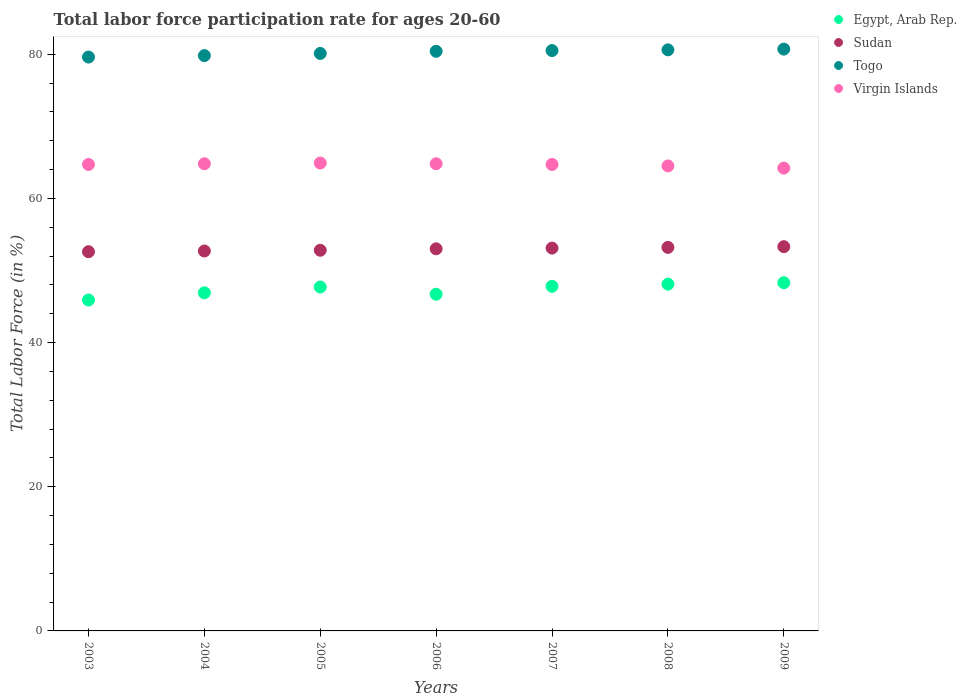What is the labor force participation rate in Egypt, Arab Rep. in 2008?
Your response must be concise. 48.1. Across all years, what is the maximum labor force participation rate in Sudan?
Keep it short and to the point. 53.3. Across all years, what is the minimum labor force participation rate in Togo?
Offer a very short reply. 79.6. In which year was the labor force participation rate in Egypt, Arab Rep. maximum?
Your answer should be compact. 2009. What is the total labor force participation rate in Sudan in the graph?
Your response must be concise. 370.7. What is the difference between the labor force participation rate in Virgin Islands in 2003 and that in 2005?
Keep it short and to the point. -0.2. What is the difference between the labor force participation rate in Sudan in 2006 and the labor force participation rate in Egypt, Arab Rep. in 2009?
Keep it short and to the point. 4.7. What is the average labor force participation rate in Virgin Islands per year?
Make the answer very short. 64.66. In the year 2007, what is the difference between the labor force participation rate in Virgin Islands and labor force participation rate in Egypt, Arab Rep.?
Keep it short and to the point. 16.9. In how many years, is the labor force participation rate in Togo greater than 72 %?
Provide a short and direct response. 7. What is the ratio of the labor force participation rate in Sudan in 2007 to that in 2009?
Offer a terse response. 1. Is the labor force participation rate in Virgin Islands in 2003 less than that in 2004?
Offer a terse response. Yes. Is the difference between the labor force participation rate in Virgin Islands in 2004 and 2009 greater than the difference between the labor force participation rate in Egypt, Arab Rep. in 2004 and 2009?
Provide a succinct answer. Yes. What is the difference between the highest and the second highest labor force participation rate in Sudan?
Your answer should be compact. 0.1. What is the difference between the highest and the lowest labor force participation rate in Sudan?
Your answer should be compact. 0.7. Is the sum of the labor force participation rate in Togo in 2007 and 2008 greater than the maximum labor force participation rate in Virgin Islands across all years?
Provide a short and direct response. Yes. Is it the case that in every year, the sum of the labor force participation rate in Virgin Islands and labor force participation rate in Sudan  is greater than the sum of labor force participation rate in Togo and labor force participation rate in Egypt, Arab Rep.?
Your response must be concise. Yes. Is it the case that in every year, the sum of the labor force participation rate in Egypt, Arab Rep. and labor force participation rate in Sudan  is greater than the labor force participation rate in Togo?
Your answer should be compact. Yes. Does the labor force participation rate in Sudan monotonically increase over the years?
Your answer should be very brief. Yes. Is the labor force participation rate in Sudan strictly greater than the labor force participation rate in Egypt, Arab Rep. over the years?
Provide a succinct answer. Yes. Are the values on the major ticks of Y-axis written in scientific E-notation?
Offer a very short reply. No. Where does the legend appear in the graph?
Make the answer very short. Top right. How are the legend labels stacked?
Your response must be concise. Vertical. What is the title of the graph?
Provide a succinct answer. Total labor force participation rate for ages 20-60. Does "Russian Federation" appear as one of the legend labels in the graph?
Your answer should be compact. No. What is the label or title of the X-axis?
Keep it short and to the point. Years. What is the label or title of the Y-axis?
Your answer should be very brief. Total Labor Force (in %). What is the Total Labor Force (in %) of Egypt, Arab Rep. in 2003?
Provide a short and direct response. 45.9. What is the Total Labor Force (in %) in Sudan in 2003?
Offer a terse response. 52.6. What is the Total Labor Force (in %) of Togo in 2003?
Ensure brevity in your answer.  79.6. What is the Total Labor Force (in %) of Virgin Islands in 2003?
Give a very brief answer. 64.7. What is the Total Labor Force (in %) in Egypt, Arab Rep. in 2004?
Provide a succinct answer. 46.9. What is the Total Labor Force (in %) of Sudan in 2004?
Your answer should be compact. 52.7. What is the Total Labor Force (in %) in Togo in 2004?
Offer a terse response. 79.8. What is the Total Labor Force (in %) of Virgin Islands in 2004?
Ensure brevity in your answer.  64.8. What is the Total Labor Force (in %) of Egypt, Arab Rep. in 2005?
Give a very brief answer. 47.7. What is the Total Labor Force (in %) in Sudan in 2005?
Your answer should be compact. 52.8. What is the Total Labor Force (in %) in Togo in 2005?
Ensure brevity in your answer.  80.1. What is the Total Labor Force (in %) of Virgin Islands in 2005?
Offer a terse response. 64.9. What is the Total Labor Force (in %) of Egypt, Arab Rep. in 2006?
Give a very brief answer. 46.7. What is the Total Labor Force (in %) in Sudan in 2006?
Give a very brief answer. 53. What is the Total Labor Force (in %) of Togo in 2006?
Make the answer very short. 80.4. What is the Total Labor Force (in %) in Virgin Islands in 2006?
Give a very brief answer. 64.8. What is the Total Labor Force (in %) in Egypt, Arab Rep. in 2007?
Your response must be concise. 47.8. What is the Total Labor Force (in %) of Sudan in 2007?
Ensure brevity in your answer.  53.1. What is the Total Labor Force (in %) of Togo in 2007?
Make the answer very short. 80.5. What is the Total Labor Force (in %) of Virgin Islands in 2007?
Your response must be concise. 64.7. What is the Total Labor Force (in %) in Egypt, Arab Rep. in 2008?
Keep it short and to the point. 48.1. What is the Total Labor Force (in %) in Sudan in 2008?
Your answer should be compact. 53.2. What is the Total Labor Force (in %) of Togo in 2008?
Provide a succinct answer. 80.6. What is the Total Labor Force (in %) of Virgin Islands in 2008?
Offer a very short reply. 64.5. What is the Total Labor Force (in %) of Egypt, Arab Rep. in 2009?
Give a very brief answer. 48.3. What is the Total Labor Force (in %) in Sudan in 2009?
Offer a terse response. 53.3. What is the Total Labor Force (in %) of Togo in 2009?
Keep it short and to the point. 80.7. What is the Total Labor Force (in %) in Virgin Islands in 2009?
Your response must be concise. 64.2. Across all years, what is the maximum Total Labor Force (in %) of Egypt, Arab Rep.?
Provide a short and direct response. 48.3. Across all years, what is the maximum Total Labor Force (in %) of Sudan?
Provide a succinct answer. 53.3. Across all years, what is the maximum Total Labor Force (in %) of Togo?
Your answer should be compact. 80.7. Across all years, what is the maximum Total Labor Force (in %) in Virgin Islands?
Your answer should be compact. 64.9. Across all years, what is the minimum Total Labor Force (in %) in Egypt, Arab Rep.?
Ensure brevity in your answer.  45.9. Across all years, what is the minimum Total Labor Force (in %) in Sudan?
Offer a terse response. 52.6. Across all years, what is the minimum Total Labor Force (in %) in Togo?
Ensure brevity in your answer.  79.6. Across all years, what is the minimum Total Labor Force (in %) of Virgin Islands?
Your answer should be very brief. 64.2. What is the total Total Labor Force (in %) in Egypt, Arab Rep. in the graph?
Your answer should be very brief. 331.4. What is the total Total Labor Force (in %) in Sudan in the graph?
Your answer should be very brief. 370.7. What is the total Total Labor Force (in %) of Togo in the graph?
Provide a short and direct response. 561.7. What is the total Total Labor Force (in %) of Virgin Islands in the graph?
Your answer should be compact. 452.6. What is the difference between the Total Labor Force (in %) of Egypt, Arab Rep. in 2003 and that in 2005?
Keep it short and to the point. -1.8. What is the difference between the Total Labor Force (in %) of Virgin Islands in 2003 and that in 2005?
Keep it short and to the point. -0.2. What is the difference between the Total Labor Force (in %) in Egypt, Arab Rep. in 2003 and that in 2006?
Offer a terse response. -0.8. What is the difference between the Total Labor Force (in %) of Sudan in 2003 and that in 2006?
Offer a very short reply. -0.4. What is the difference between the Total Labor Force (in %) of Togo in 2003 and that in 2006?
Offer a very short reply. -0.8. What is the difference between the Total Labor Force (in %) in Egypt, Arab Rep. in 2003 and that in 2007?
Offer a very short reply. -1.9. What is the difference between the Total Labor Force (in %) of Togo in 2003 and that in 2007?
Provide a short and direct response. -0.9. What is the difference between the Total Labor Force (in %) in Virgin Islands in 2003 and that in 2007?
Provide a short and direct response. 0. What is the difference between the Total Labor Force (in %) of Sudan in 2003 and that in 2008?
Your answer should be compact. -0.6. What is the difference between the Total Labor Force (in %) in Togo in 2003 and that in 2008?
Provide a succinct answer. -1. What is the difference between the Total Labor Force (in %) of Sudan in 2003 and that in 2009?
Give a very brief answer. -0.7. What is the difference between the Total Labor Force (in %) of Togo in 2003 and that in 2009?
Make the answer very short. -1.1. What is the difference between the Total Labor Force (in %) in Egypt, Arab Rep. in 2004 and that in 2005?
Provide a succinct answer. -0.8. What is the difference between the Total Labor Force (in %) of Sudan in 2004 and that in 2005?
Your answer should be very brief. -0.1. What is the difference between the Total Labor Force (in %) of Togo in 2004 and that in 2005?
Offer a terse response. -0.3. What is the difference between the Total Labor Force (in %) of Virgin Islands in 2004 and that in 2005?
Offer a terse response. -0.1. What is the difference between the Total Labor Force (in %) in Egypt, Arab Rep. in 2004 and that in 2006?
Keep it short and to the point. 0.2. What is the difference between the Total Labor Force (in %) in Togo in 2004 and that in 2006?
Make the answer very short. -0.6. What is the difference between the Total Labor Force (in %) of Virgin Islands in 2004 and that in 2006?
Provide a succinct answer. 0. What is the difference between the Total Labor Force (in %) of Egypt, Arab Rep. in 2004 and that in 2007?
Offer a very short reply. -0.9. What is the difference between the Total Labor Force (in %) of Egypt, Arab Rep. in 2004 and that in 2008?
Keep it short and to the point. -1.2. What is the difference between the Total Labor Force (in %) of Sudan in 2004 and that in 2008?
Give a very brief answer. -0.5. What is the difference between the Total Labor Force (in %) in Virgin Islands in 2004 and that in 2008?
Your answer should be compact. 0.3. What is the difference between the Total Labor Force (in %) of Egypt, Arab Rep. in 2004 and that in 2009?
Offer a very short reply. -1.4. What is the difference between the Total Labor Force (in %) of Togo in 2004 and that in 2009?
Provide a succinct answer. -0.9. What is the difference between the Total Labor Force (in %) of Virgin Islands in 2004 and that in 2009?
Your answer should be very brief. 0.6. What is the difference between the Total Labor Force (in %) in Sudan in 2005 and that in 2006?
Offer a terse response. -0.2. What is the difference between the Total Labor Force (in %) of Togo in 2005 and that in 2006?
Keep it short and to the point. -0.3. What is the difference between the Total Labor Force (in %) in Togo in 2005 and that in 2007?
Keep it short and to the point. -0.4. What is the difference between the Total Labor Force (in %) in Virgin Islands in 2005 and that in 2007?
Offer a very short reply. 0.2. What is the difference between the Total Labor Force (in %) of Virgin Islands in 2005 and that in 2008?
Your answer should be compact. 0.4. What is the difference between the Total Labor Force (in %) of Sudan in 2005 and that in 2009?
Offer a very short reply. -0.5. What is the difference between the Total Labor Force (in %) in Togo in 2005 and that in 2009?
Your answer should be very brief. -0.6. What is the difference between the Total Labor Force (in %) in Egypt, Arab Rep. in 2006 and that in 2008?
Give a very brief answer. -1.4. What is the difference between the Total Labor Force (in %) of Togo in 2006 and that in 2009?
Offer a very short reply. -0.3. What is the difference between the Total Labor Force (in %) in Sudan in 2007 and that in 2008?
Ensure brevity in your answer.  -0.1. What is the difference between the Total Labor Force (in %) of Togo in 2007 and that in 2008?
Ensure brevity in your answer.  -0.1. What is the difference between the Total Labor Force (in %) of Egypt, Arab Rep. in 2007 and that in 2009?
Your response must be concise. -0.5. What is the difference between the Total Labor Force (in %) in Togo in 2007 and that in 2009?
Your response must be concise. -0.2. What is the difference between the Total Labor Force (in %) in Virgin Islands in 2008 and that in 2009?
Make the answer very short. 0.3. What is the difference between the Total Labor Force (in %) in Egypt, Arab Rep. in 2003 and the Total Labor Force (in %) in Togo in 2004?
Ensure brevity in your answer.  -33.9. What is the difference between the Total Labor Force (in %) in Egypt, Arab Rep. in 2003 and the Total Labor Force (in %) in Virgin Islands in 2004?
Offer a very short reply. -18.9. What is the difference between the Total Labor Force (in %) in Sudan in 2003 and the Total Labor Force (in %) in Togo in 2004?
Offer a very short reply. -27.2. What is the difference between the Total Labor Force (in %) of Togo in 2003 and the Total Labor Force (in %) of Virgin Islands in 2004?
Offer a terse response. 14.8. What is the difference between the Total Labor Force (in %) in Egypt, Arab Rep. in 2003 and the Total Labor Force (in %) in Sudan in 2005?
Your answer should be compact. -6.9. What is the difference between the Total Labor Force (in %) of Egypt, Arab Rep. in 2003 and the Total Labor Force (in %) of Togo in 2005?
Offer a very short reply. -34.2. What is the difference between the Total Labor Force (in %) of Egypt, Arab Rep. in 2003 and the Total Labor Force (in %) of Virgin Islands in 2005?
Provide a short and direct response. -19. What is the difference between the Total Labor Force (in %) of Sudan in 2003 and the Total Labor Force (in %) of Togo in 2005?
Ensure brevity in your answer.  -27.5. What is the difference between the Total Labor Force (in %) in Egypt, Arab Rep. in 2003 and the Total Labor Force (in %) in Sudan in 2006?
Ensure brevity in your answer.  -7.1. What is the difference between the Total Labor Force (in %) in Egypt, Arab Rep. in 2003 and the Total Labor Force (in %) in Togo in 2006?
Provide a short and direct response. -34.5. What is the difference between the Total Labor Force (in %) of Egypt, Arab Rep. in 2003 and the Total Labor Force (in %) of Virgin Islands in 2006?
Give a very brief answer. -18.9. What is the difference between the Total Labor Force (in %) of Sudan in 2003 and the Total Labor Force (in %) of Togo in 2006?
Keep it short and to the point. -27.8. What is the difference between the Total Labor Force (in %) in Sudan in 2003 and the Total Labor Force (in %) in Virgin Islands in 2006?
Offer a terse response. -12.2. What is the difference between the Total Labor Force (in %) of Egypt, Arab Rep. in 2003 and the Total Labor Force (in %) of Togo in 2007?
Provide a succinct answer. -34.6. What is the difference between the Total Labor Force (in %) in Egypt, Arab Rep. in 2003 and the Total Labor Force (in %) in Virgin Islands in 2007?
Ensure brevity in your answer.  -18.8. What is the difference between the Total Labor Force (in %) in Sudan in 2003 and the Total Labor Force (in %) in Togo in 2007?
Provide a succinct answer. -27.9. What is the difference between the Total Labor Force (in %) in Sudan in 2003 and the Total Labor Force (in %) in Virgin Islands in 2007?
Your answer should be compact. -12.1. What is the difference between the Total Labor Force (in %) of Egypt, Arab Rep. in 2003 and the Total Labor Force (in %) of Sudan in 2008?
Offer a terse response. -7.3. What is the difference between the Total Labor Force (in %) in Egypt, Arab Rep. in 2003 and the Total Labor Force (in %) in Togo in 2008?
Offer a terse response. -34.7. What is the difference between the Total Labor Force (in %) in Egypt, Arab Rep. in 2003 and the Total Labor Force (in %) in Virgin Islands in 2008?
Ensure brevity in your answer.  -18.6. What is the difference between the Total Labor Force (in %) of Sudan in 2003 and the Total Labor Force (in %) of Togo in 2008?
Your answer should be compact. -28. What is the difference between the Total Labor Force (in %) in Sudan in 2003 and the Total Labor Force (in %) in Virgin Islands in 2008?
Your answer should be compact. -11.9. What is the difference between the Total Labor Force (in %) of Egypt, Arab Rep. in 2003 and the Total Labor Force (in %) of Togo in 2009?
Offer a very short reply. -34.8. What is the difference between the Total Labor Force (in %) in Egypt, Arab Rep. in 2003 and the Total Labor Force (in %) in Virgin Islands in 2009?
Offer a terse response. -18.3. What is the difference between the Total Labor Force (in %) of Sudan in 2003 and the Total Labor Force (in %) of Togo in 2009?
Offer a very short reply. -28.1. What is the difference between the Total Labor Force (in %) in Egypt, Arab Rep. in 2004 and the Total Labor Force (in %) in Togo in 2005?
Keep it short and to the point. -33.2. What is the difference between the Total Labor Force (in %) in Sudan in 2004 and the Total Labor Force (in %) in Togo in 2005?
Your answer should be compact. -27.4. What is the difference between the Total Labor Force (in %) of Sudan in 2004 and the Total Labor Force (in %) of Virgin Islands in 2005?
Your response must be concise. -12.2. What is the difference between the Total Labor Force (in %) in Egypt, Arab Rep. in 2004 and the Total Labor Force (in %) in Togo in 2006?
Offer a terse response. -33.5. What is the difference between the Total Labor Force (in %) in Egypt, Arab Rep. in 2004 and the Total Labor Force (in %) in Virgin Islands in 2006?
Make the answer very short. -17.9. What is the difference between the Total Labor Force (in %) of Sudan in 2004 and the Total Labor Force (in %) of Togo in 2006?
Your answer should be compact. -27.7. What is the difference between the Total Labor Force (in %) of Sudan in 2004 and the Total Labor Force (in %) of Virgin Islands in 2006?
Your response must be concise. -12.1. What is the difference between the Total Labor Force (in %) in Togo in 2004 and the Total Labor Force (in %) in Virgin Islands in 2006?
Keep it short and to the point. 15. What is the difference between the Total Labor Force (in %) in Egypt, Arab Rep. in 2004 and the Total Labor Force (in %) in Sudan in 2007?
Make the answer very short. -6.2. What is the difference between the Total Labor Force (in %) of Egypt, Arab Rep. in 2004 and the Total Labor Force (in %) of Togo in 2007?
Your response must be concise. -33.6. What is the difference between the Total Labor Force (in %) of Egypt, Arab Rep. in 2004 and the Total Labor Force (in %) of Virgin Islands in 2007?
Your answer should be very brief. -17.8. What is the difference between the Total Labor Force (in %) in Sudan in 2004 and the Total Labor Force (in %) in Togo in 2007?
Your answer should be compact. -27.8. What is the difference between the Total Labor Force (in %) in Sudan in 2004 and the Total Labor Force (in %) in Virgin Islands in 2007?
Provide a short and direct response. -12. What is the difference between the Total Labor Force (in %) in Togo in 2004 and the Total Labor Force (in %) in Virgin Islands in 2007?
Your answer should be very brief. 15.1. What is the difference between the Total Labor Force (in %) in Egypt, Arab Rep. in 2004 and the Total Labor Force (in %) in Sudan in 2008?
Your answer should be very brief. -6.3. What is the difference between the Total Labor Force (in %) in Egypt, Arab Rep. in 2004 and the Total Labor Force (in %) in Togo in 2008?
Your answer should be very brief. -33.7. What is the difference between the Total Labor Force (in %) of Egypt, Arab Rep. in 2004 and the Total Labor Force (in %) of Virgin Islands in 2008?
Make the answer very short. -17.6. What is the difference between the Total Labor Force (in %) of Sudan in 2004 and the Total Labor Force (in %) of Togo in 2008?
Ensure brevity in your answer.  -27.9. What is the difference between the Total Labor Force (in %) in Egypt, Arab Rep. in 2004 and the Total Labor Force (in %) in Togo in 2009?
Keep it short and to the point. -33.8. What is the difference between the Total Labor Force (in %) in Egypt, Arab Rep. in 2004 and the Total Labor Force (in %) in Virgin Islands in 2009?
Offer a terse response. -17.3. What is the difference between the Total Labor Force (in %) of Togo in 2004 and the Total Labor Force (in %) of Virgin Islands in 2009?
Offer a terse response. 15.6. What is the difference between the Total Labor Force (in %) in Egypt, Arab Rep. in 2005 and the Total Labor Force (in %) in Togo in 2006?
Keep it short and to the point. -32.7. What is the difference between the Total Labor Force (in %) of Egypt, Arab Rep. in 2005 and the Total Labor Force (in %) of Virgin Islands in 2006?
Your answer should be compact. -17.1. What is the difference between the Total Labor Force (in %) in Sudan in 2005 and the Total Labor Force (in %) in Togo in 2006?
Your answer should be very brief. -27.6. What is the difference between the Total Labor Force (in %) of Sudan in 2005 and the Total Labor Force (in %) of Virgin Islands in 2006?
Make the answer very short. -12. What is the difference between the Total Labor Force (in %) of Togo in 2005 and the Total Labor Force (in %) of Virgin Islands in 2006?
Keep it short and to the point. 15.3. What is the difference between the Total Labor Force (in %) in Egypt, Arab Rep. in 2005 and the Total Labor Force (in %) in Sudan in 2007?
Give a very brief answer. -5.4. What is the difference between the Total Labor Force (in %) of Egypt, Arab Rep. in 2005 and the Total Labor Force (in %) of Togo in 2007?
Offer a very short reply. -32.8. What is the difference between the Total Labor Force (in %) of Egypt, Arab Rep. in 2005 and the Total Labor Force (in %) of Virgin Islands in 2007?
Ensure brevity in your answer.  -17. What is the difference between the Total Labor Force (in %) in Sudan in 2005 and the Total Labor Force (in %) in Togo in 2007?
Ensure brevity in your answer.  -27.7. What is the difference between the Total Labor Force (in %) of Togo in 2005 and the Total Labor Force (in %) of Virgin Islands in 2007?
Offer a terse response. 15.4. What is the difference between the Total Labor Force (in %) of Egypt, Arab Rep. in 2005 and the Total Labor Force (in %) of Togo in 2008?
Provide a succinct answer. -32.9. What is the difference between the Total Labor Force (in %) of Egypt, Arab Rep. in 2005 and the Total Labor Force (in %) of Virgin Islands in 2008?
Offer a very short reply. -16.8. What is the difference between the Total Labor Force (in %) of Sudan in 2005 and the Total Labor Force (in %) of Togo in 2008?
Your response must be concise. -27.8. What is the difference between the Total Labor Force (in %) of Sudan in 2005 and the Total Labor Force (in %) of Virgin Islands in 2008?
Ensure brevity in your answer.  -11.7. What is the difference between the Total Labor Force (in %) in Togo in 2005 and the Total Labor Force (in %) in Virgin Islands in 2008?
Offer a terse response. 15.6. What is the difference between the Total Labor Force (in %) of Egypt, Arab Rep. in 2005 and the Total Labor Force (in %) of Togo in 2009?
Keep it short and to the point. -33. What is the difference between the Total Labor Force (in %) in Egypt, Arab Rep. in 2005 and the Total Labor Force (in %) in Virgin Islands in 2009?
Offer a terse response. -16.5. What is the difference between the Total Labor Force (in %) in Sudan in 2005 and the Total Labor Force (in %) in Togo in 2009?
Your response must be concise. -27.9. What is the difference between the Total Labor Force (in %) in Sudan in 2005 and the Total Labor Force (in %) in Virgin Islands in 2009?
Make the answer very short. -11.4. What is the difference between the Total Labor Force (in %) of Egypt, Arab Rep. in 2006 and the Total Labor Force (in %) of Sudan in 2007?
Make the answer very short. -6.4. What is the difference between the Total Labor Force (in %) of Egypt, Arab Rep. in 2006 and the Total Labor Force (in %) of Togo in 2007?
Offer a very short reply. -33.8. What is the difference between the Total Labor Force (in %) of Egypt, Arab Rep. in 2006 and the Total Labor Force (in %) of Virgin Islands in 2007?
Your answer should be compact. -18. What is the difference between the Total Labor Force (in %) in Sudan in 2006 and the Total Labor Force (in %) in Togo in 2007?
Ensure brevity in your answer.  -27.5. What is the difference between the Total Labor Force (in %) of Sudan in 2006 and the Total Labor Force (in %) of Virgin Islands in 2007?
Give a very brief answer. -11.7. What is the difference between the Total Labor Force (in %) of Egypt, Arab Rep. in 2006 and the Total Labor Force (in %) of Togo in 2008?
Ensure brevity in your answer.  -33.9. What is the difference between the Total Labor Force (in %) of Egypt, Arab Rep. in 2006 and the Total Labor Force (in %) of Virgin Islands in 2008?
Make the answer very short. -17.8. What is the difference between the Total Labor Force (in %) in Sudan in 2006 and the Total Labor Force (in %) in Togo in 2008?
Keep it short and to the point. -27.6. What is the difference between the Total Labor Force (in %) of Sudan in 2006 and the Total Labor Force (in %) of Virgin Islands in 2008?
Provide a short and direct response. -11.5. What is the difference between the Total Labor Force (in %) of Togo in 2006 and the Total Labor Force (in %) of Virgin Islands in 2008?
Offer a terse response. 15.9. What is the difference between the Total Labor Force (in %) in Egypt, Arab Rep. in 2006 and the Total Labor Force (in %) in Sudan in 2009?
Your answer should be very brief. -6.6. What is the difference between the Total Labor Force (in %) in Egypt, Arab Rep. in 2006 and the Total Labor Force (in %) in Togo in 2009?
Offer a very short reply. -34. What is the difference between the Total Labor Force (in %) in Egypt, Arab Rep. in 2006 and the Total Labor Force (in %) in Virgin Islands in 2009?
Your answer should be very brief. -17.5. What is the difference between the Total Labor Force (in %) of Sudan in 2006 and the Total Labor Force (in %) of Togo in 2009?
Ensure brevity in your answer.  -27.7. What is the difference between the Total Labor Force (in %) of Sudan in 2006 and the Total Labor Force (in %) of Virgin Islands in 2009?
Provide a short and direct response. -11.2. What is the difference between the Total Labor Force (in %) in Togo in 2006 and the Total Labor Force (in %) in Virgin Islands in 2009?
Provide a succinct answer. 16.2. What is the difference between the Total Labor Force (in %) in Egypt, Arab Rep. in 2007 and the Total Labor Force (in %) in Togo in 2008?
Give a very brief answer. -32.8. What is the difference between the Total Labor Force (in %) of Egypt, Arab Rep. in 2007 and the Total Labor Force (in %) of Virgin Islands in 2008?
Provide a succinct answer. -16.7. What is the difference between the Total Labor Force (in %) of Sudan in 2007 and the Total Labor Force (in %) of Togo in 2008?
Give a very brief answer. -27.5. What is the difference between the Total Labor Force (in %) of Sudan in 2007 and the Total Labor Force (in %) of Virgin Islands in 2008?
Offer a very short reply. -11.4. What is the difference between the Total Labor Force (in %) in Togo in 2007 and the Total Labor Force (in %) in Virgin Islands in 2008?
Give a very brief answer. 16. What is the difference between the Total Labor Force (in %) in Egypt, Arab Rep. in 2007 and the Total Labor Force (in %) in Togo in 2009?
Provide a succinct answer. -32.9. What is the difference between the Total Labor Force (in %) of Egypt, Arab Rep. in 2007 and the Total Labor Force (in %) of Virgin Islands in 2009?
Your answer should be compact. -16.4. What is the difference between the Total Labor Force (in %) in Sudan in 2007 and the Total Labor Force (in %) in Togo in 2009?
Keep it short and to the point. -27.6. What is the difference between the Total Labor Force (in %) in Togo in 2007 and the Total Labor Force (in %) in Virgin Islands in 2009?
Give a very brief answer. 16.3. What is the difference between the Total Labor Force (in %) in Egypt, Arab Rep. in 2008 and the Total Labor Force (in %) in Togo in 2009?
Give a very brief answer. -32.6. What is the difference between the Total Labor Force (in %) of Egypt, Arab Rep. in 2008 and the Total Labor Force (in %) of Virgin Islands in 2009?
Your response must be concise. -16.1. What is the difference between the Total Labor Force (in %) in Sudan in 2008 and the Total Labor Force (in %) in Togo in 2009?
Keep it short and to the point. -27.5. What is the average Total Labor Force (in %) in Egypt, Arab Rep. per year?
Provide a succinct answer. 47.34. What is the average Total Labor Force (in %) of Sudan per year?
Ensure brevity in your answer.  52.96. What is the average Total Labor Force (in %) of Togo per year?
Give a very brief answer. 80.24. What is the average Total Labor Force (in %) in Virgin Islands per year?
Keep it short and to the point. 64.66. In the year 2003, what is the difference between the Total Labor Force (in %) in Egypt, Arab Rep. and Total Labor Force (in %) in Togo?
Provide a succinct answer. -33.7. In the year 2003, what is the difference between the Total Labor Force (in %) in Egypt, Arab Rep. and Total Labor Force (in %) in Virgin Islands?
Make the answer very short. -18.8. In the year 2004, what is the difference between the Total Labor Force (in %) of Egypt, Arab Rep. and Total Labor Force (in %) of Sudan?
Offer a terse response. -5.8. In the year 2004, what is the difference between the Total Labor Force (in %) of Egypt, Arab Rep. and Total Labor Force (in %) of Togo?
Your answer should be very brief. -32.9. In the year 2004, what is the difference between the Total Labor Force (in %) in Egypt, Arab Rep. and Total Labor Force (in %) in Virgin Islands?
Your answer should be compact. -17.9. In the year 2004, what is the difference between the Total Labor Force (in %) in Sudan and Total Labor Force (in %) in Togo?
Ensure brevity in your answer.  -27.1. In the year 2004, what is the difference between the Total Labor Force (in %) of Togo and Total Labor Force (in %) of Virgin Islands?
Offer a very short reply. 15. In the year 2005, what is the difference between the Total Labor Force (in %) in Egypt, Arab Rep. and Total Labor Force (in %) in Sudan?
Ensure brevity in your answer.  -5.1. In the year 2005, what is the difference between the Total Labor Force (in %) of Egypt, Arab Rep. and Total Labor Force (in %) of Togo?
Your response must be concise. -32.4. In the year 2005, what is the difference between the Total Labor Force (in %) of Egypt, Arab Rep. and Total Labor Force (in %) of Virgin Islands?
Your response must be concise. -17.2. In the year 2005, what is the difference between the Total Labor Force (in %) of Sudan and Total Labor Force (in %) of Togo?
Your response must be concise. -27.3. In the year 2005, what is the difference between the Total Labor Force (in %) of Togo and Total Labor Force (in %) of Virgin Islands?
Your answer should be compact. 15.2. In the year 2006, what is the difference between the Total Labor Force (in %) in Egypt, Arab Rep. and Total Labor Force (in %) in Sudan?
Offer a terse response. -6.3. In the year 2006, what is the difference between the Total Labor Force (in %) in Egypt, Arab Rep. and Total Labor Force (in %) in Togo?
Provide a succinct answer. -33.7. In the year 2006, what is the difference between the Total Labor Force (in %) of Egypt, Arab Rep. and Total Labor Force (in %) of Virgin Islands?
Ensure brevity in your answer.  -18.1. In the year 2006, what is the difference between the Total Labor Force (in %) of Sudan and Total Labor Force (in %) of Togo?
Your answer should be very brief. -27.4. In the year 2007, what is the difference between the Total Labor Force (in %) of Egypt, Arab Rep. and Total Labor Force (in %) of Sudan?
Provide a succinct answer. -5.3. In the year 2007, what is the difference between the Total Labor Force (in %) in Egypt, Arab Rep. and Total Labor Force (in %) in Togo?
Your response must be concise. -32.7. In the year 2007, what is the difference between the Total Labor Force (in %) of Egypt, Arab Rep. and Total Labor Force (in %) of Virgin Islands?
Provide a succinct answer. -16.9. In the year 2007, what is the difference between the Total Labor Force (in %) in Sudan and Total Labor Force (in %) in Togo?
Your answer should be compact. -27.4. In the year 2008, what is the difference between the Total Labor Force (in %) of Egypt, Arab Rep. and Total Labor Force (in %) of Togo?
Provide a short and direct response. -32.5. In the year 2008, what is the difference between the Total Labor Force (in %) in Egypt, Arab Rep. and Total Labor Force (in %) in Virgin Islands?
Your answer should be compact. -16.4. In the year 2008, what is the difference between the Total Labor Force (in %) of Sudan and Total Labor Force (in %) of Togo?
Provide a short and direct response. -27.4. In the year 2008, what is the difference between the Total Labor Force (in %) of Togo and Total Labor Force (in %) of Virgin Islands?
Your answer should be compact. 16.1. In the year 2009, what is the difference between the Total Labor Force (in %) in Egypt, Arab Rep. and Total Labor Force (in %) in Togo?
Keep it short and to the point. -32.4. In the year 2009, what is the difference between the Total Labor Force (in %) in Egypt, Arab Rep. and Total Labor Force (in %) in Virgin Islands?
Provide a succinct answer. -15.9. In the year 2009, what is the difference between the Total Labor Force (in %) in Sudan and Total Labor Force (in %) in Togo?
Offer a terse response. -27.4. In the year 2009, what is the difference between the Total Labor Force (in %) of Togo and Total Labor Force (in %) of Virgin Islands?
Provide a succinct answer. 16.5. What is the ratio of the Total Labor Force (in %) in Egypt, Arab Rep. in 2003 to that in 2004?
Provide a short and direct response. 0.98. What is the ratio of the Total Labor Force (in %) in Egypt, Arab Rep. in 2003 to that in 2005?
Provide a succinct answer. 0.96. What is the ratio of the Total Labor Force (in %) of Sudan in 2003 to that in 2005?
Your answer should be compact. 1. What is the ratio of the Total Labor Force (in %) of Virgin Islands in 2003 to that in 2005?
Ensure brevity in your answer.  1. What is the ratio of the Total Labor Force (in %) of Egypt, Arab Rep. in 2003 to that in 2006?
Your response must be concise. 0.98. What is the ratio of the Total Labor Force (in %) of Togo in 2003 to that in 2006?
Provide a short and direct response. 0.99. What is the ratio of the Total Labor Force (in %) of Egypt, Arab Rep. in 2003 to that in 2007?
Offer a terse response. 0.96. What is the ratio of the Total Labor Force (in %) in Sudan in 2003 to that in 2007?
Keep it short and to the point. 0.99. What is the ratio of the Total Labor Force (in %) in Egypt, Arab Rep. in 2003 to that in 2008?
Your response must be concise. 0.95. What is the ratio of the Total Labor Force (in %) in Sudan in 2003 to that in 2008?
Give a very brief answer. 0.99. What is the ratio of the Total Labor Force (in %) of Togo in 2003 to that in 2008?
Keep it short and to the point. 0.99. What is the ratio of the Total Labor Force (in %) in Egypt, Arab Rep. in 2003 to that in 2009?
Offer a very short reply. 0.95. What is the ratio of the Total Labor Force (in %) in Sudan in 2003 to that in 2009?
Your answer should be compact. 0.99. What is the ratio of the Total Labor Force (in %) of Togo in 2003 to that in 2009?
Give a very brief answer. 0.99. What is the ratio of the Total Labor Force (in %) in Virgin Islands in 2003 to that in 2009?
Keep it short and to the point. 1.01. What is the ratio of the Total Labor Force (in %) of Egypt, Arab Rep. in 2004 to that in 2005?
Keep it short and to the point. 0.98. What is the ratio of the Total Labor Force (in %) in Sudan in 2004 to that in 2005?
Make the answer very short. 1. What is the ratio of the Total Labor Force (in %) of Togo in 2004 to that in 2005?
Keep it short and to the point. 1. What is the ratio of the Total Labor Force (in %) of Virgin Islands in 2004 to that in 2005?
Your answer should be very brief. 1. What is the ratio of the Total Labor Force (in %) of Egypt, Arab Rep. in 2004 to that in 2006?
Ensure brevity in your answer.  1. What is the ratio of the Total Labor Force (in %) in Egypt, Arab Rep. in 2004 to that in 2007?
Your answer should be very brief. 0.98. What is the ratio of the Total Labor Force (in %) in Sudan in 2004 to that in 2007?
Your answer should be very brief. 0.99. What is the ratio of the Total Labor Force (in %) of Togo in 2004 to that in 2007?
Your answer should be very brief. 0.99. What is the ratio of the Total Labor Force (in %) in Virgin Islands in 2004 to that in 2007?
Give a very brief answer. 1. What is the ratio of the Total Labor Force (in %) of Egypt, Arab Rep. in 2004 to that in 2008?
Ensure brevity in your answer.  0.98. What is the ratio of the Total Labor Force (in %) of Sudan in 2004 to that in 2008?
Keep it short and to the point. 0.99. What is the ratio of the Total Labor Force (in %) in Virgin Islands in 2004 to that in 2008?
Offer a very short reply. 1. What is the ratio of the Total Labor Force (in %) of Sudan in 2004 to that in 2009?
Provide a succinct answer. 0.99. What is the ratio of the Total Labor Force (in %) of Togo in 2004 to that in 2009?
Your response must be concise. 0.99. What is the ratio of the Total Labor Force (in %) in Virgin Islands in 2004 to that in 2009?
Provide a succinct answer. 1.01. What is the ratio of the Total Labor Force (in %) in Egypt, Arab Rep. in 2005 to that in 2006?
Offer a terse response. 1.02. What is the ratio of the Total Labor Force (in %) of Sudan in 2005 to that in 2006?
Ensure brevity in your answer.  1. What is the ratio of the Total Labor Force (in %) of Virgin Islands in 2005 to that in 2006?
Provide a succinct answer. 1. What is the ratio of the Total Labor Force (in %) in Egypt, Arab Rep. in 2005 to that in 2007?
Provide a short and direct response. 1. What is the ratio of the Total Labor Force (in %) in Togo in 2005 to that in 2007?
Your answer should be compact. 0.99. What is the ratio of the Total Labor Force (in %) of Egypt, Arab Rep. in 2005 to that in 2008?
Your response must be concise. 0.99. What is the ratio of the Total Labor Force (in %) of Togo in 2005 to that in 2008?
Provide a short and direct response. 0.99. What is the ratio of the Total Labor Force (in %) in Egypt, Arab Rep. in 2005 to that in 2009?
Provide a succinct answer. 0.99. What is the ratio of the Total Labor Force (in %) in Sudan in 2005 to that in 2009?
Keep it short and to the point. 0.99. What is the ratio of the Total Labor Force (in %) in Virgin Islands in 2005 to that in 2009?
Your answer should be compact. 1.01. What is the ratio of the Total Labor Force (in %) of Egypt, Arab Rep. in 2006 to that in 2007?
Your answer should be compact. 0.98. What is the ratio of the Total Labor Force (in %) of Togo in 2006 to that in 2007?
Provide a short and direct response. 1. What is the ratio of the Total Labor Force (in %) of Virgin Islands in 2006 to that in 2007?
Your answer should be very brief. 1. What is the ratio of the Total Labor Force (in %) in Egypt, Arab Rep. in 2006 to that in 2008?
Offer a terse response. 0.97. What is the ratio of the Total Labor Force (in %) of Sudan in 2006 to that in 2008?
Keep it short and to the point. 1. What is the ratio of the Total Labor Force (in %) in Egypt, Arab Rep. in 2006 to that in 2009?
Your response must be concise. 0.97. What is the ratio of the Total Labor Force (in %) in Togo in 2006 to that in 2009?
Keep it short and to the point. 1. What is the ratio of the Total Labor Force (in %) in Virgin Islands in 2006 to that in 2009?
Offer a terse response. 1.01. What is the ratio of the Total Labor Force (in %) of Sudan in 2007 to that in 2008?
Provide a succinct answer. 1. What is the ratio of the Total Labor Force (in %) of Sudan in 2007 to that in 2009?
Keep it short and to the point. 1. What is the ratio of the Total Labor Force (in %) of Egypt, Arab Rep. in 2008 to that in 2009?
Your answer should be very brief. 1. What is the ratio of the Total Labor Force (in %) of Virgin Islands in 2008 to that in 2009?
Provide a short and direct response. 1. What is the difference between the highest and the second highest Total Labor Force (in %) in Egypt, Arab Rep.?
Keep it short and to the point. 0.2. What is the difference between the highest and the second highest Total Labor Force (in %) of Togo?
Provide a succinct answer. 0.1. What is the difference between the highest and the lowest Total Labor Force (in %) in Togo?
Your answer should be compact. 1.1. What is the difference between the highest and the lowest Total Labor Force (in %) of Virgin Islands?
Offer a terse response. 0.7. 